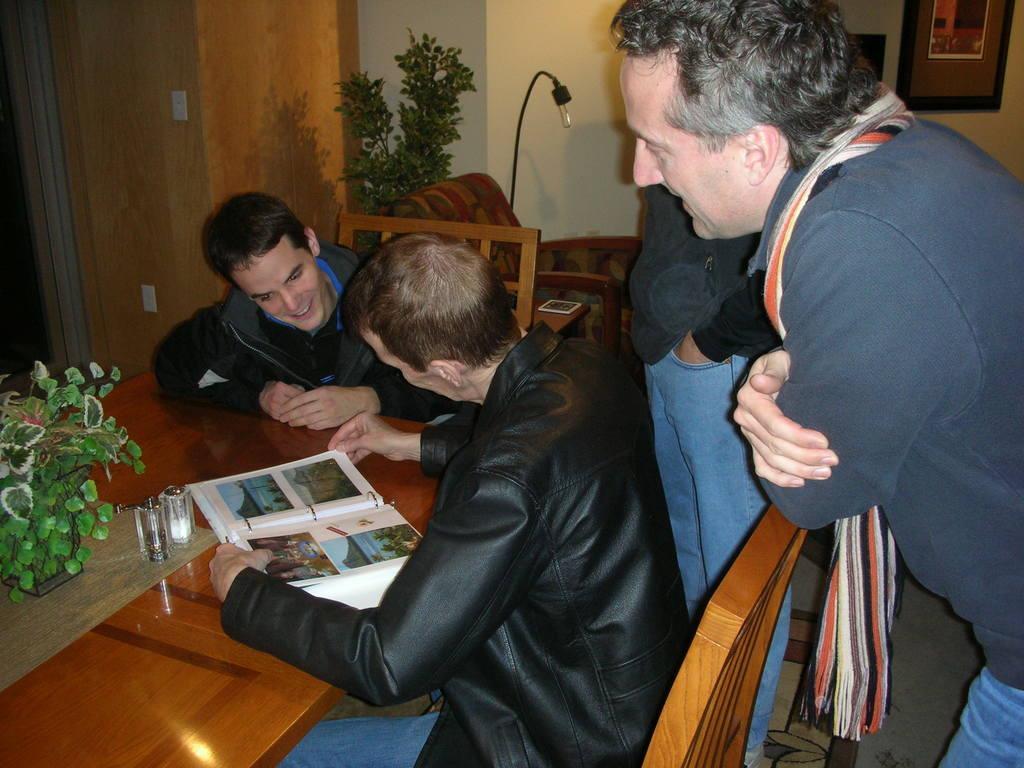How would you summarize this image in a sentence or two? In this picture we can see four men where two are standing and two are sitting on chairs and in front of them on table we have book, vase with flower in it and in the background we can see wall, plant, light, frames. 